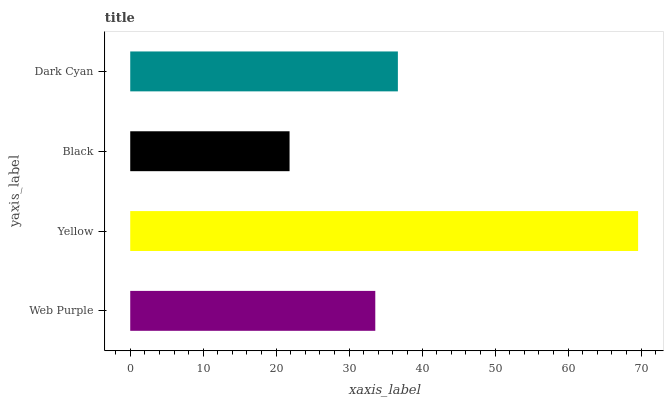Is Black the minimum?
Answer yes or no. Yes. Is Yellow the maximum?
Answer yes or no. Yes. Is Yellow the minimum?
Answer yes or no. No. Is Black the maximum?
Answer yes or no. No. Is Yellow greater than Black?
Answer yes or no. Yes. Is Black less than Yellow?
Answer yes or no. Yes. Is Black greater than Yellow?
Answer yes or no. No. Is Yellow less than Black?
Answer yes or no. No. Is Dark Cyan the high median?
Answer yes or no. Yes. Is Web Purple the low median?
Answer yes or no. Yes. Is Yellow the high median?
Answer yes or no. No. Is Yellow the low median?
Answer yes or no. No. 